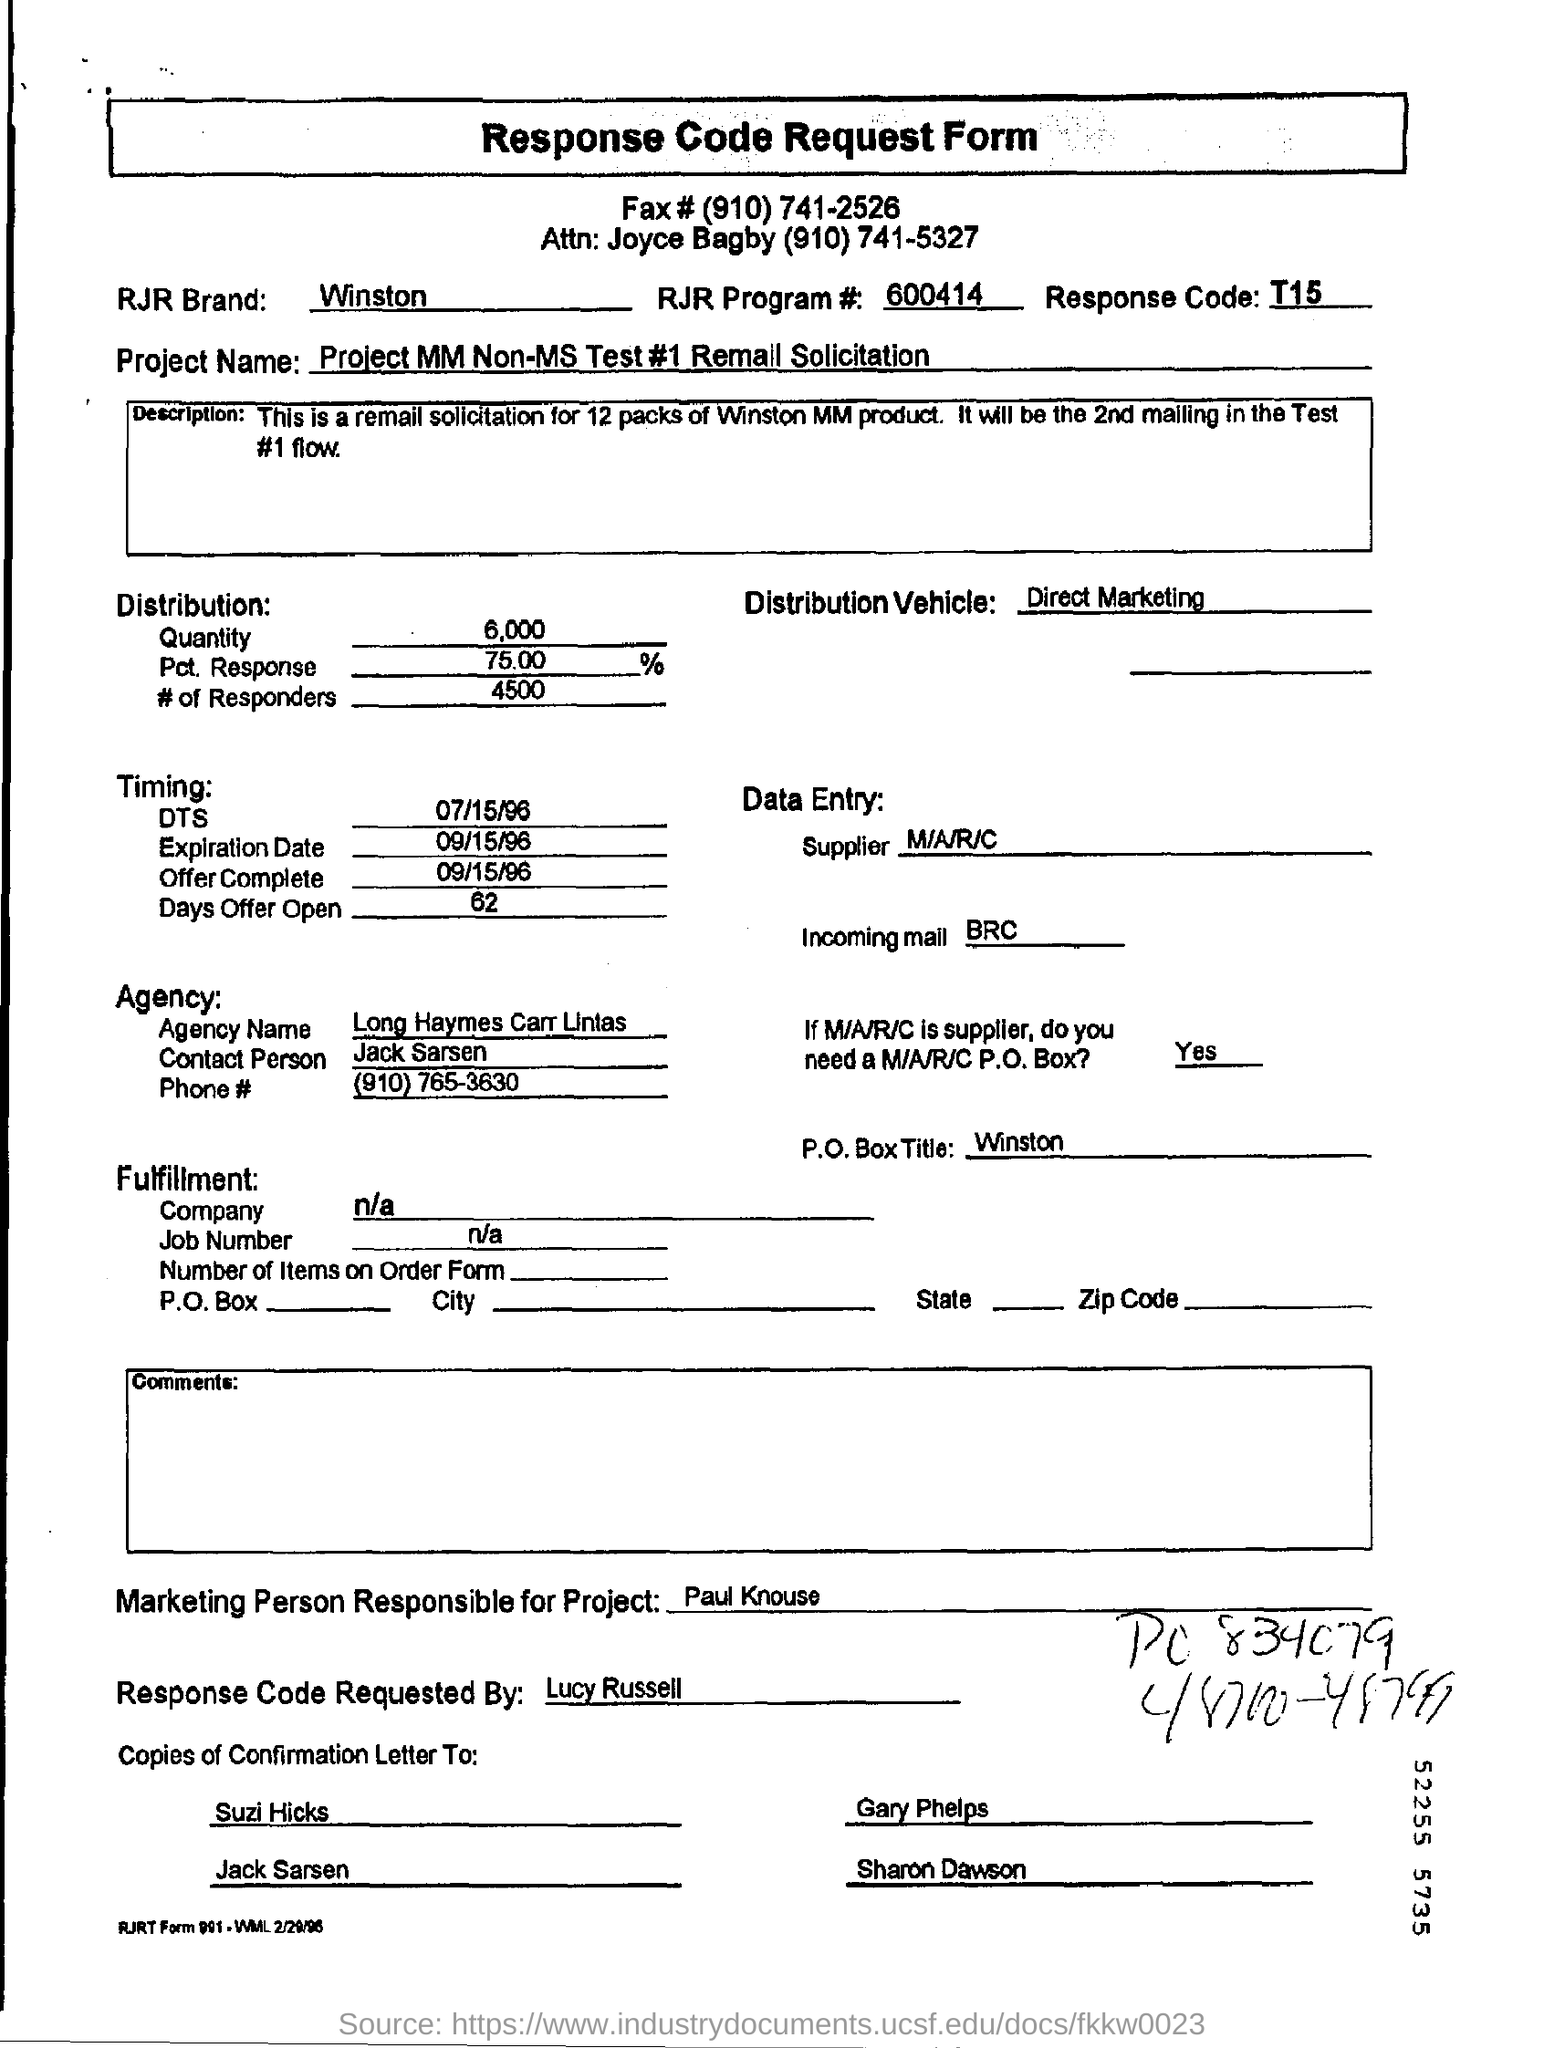Who Requested Response Code ?
Keep it short and to the point. Lucy Russell. Which form is this?
Your answer should be compact. Response Code Request Form. What is the Project Name given in this form?
Your response must be concise. Project MM Non-MS Test #1 Remall Solicitation. Who is Responsible for Project Marketing?
Your answer should be compact. Paul Knouse. 